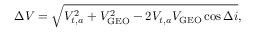<formula> <loc_0><loc_0><loc_500><loc_500>\Delta V = { \sqrt { V _ { t , a } ^ { 2 } + V _ { G E O } ^ { 2 } - 2 V _ { t , a } V _ { G E O } \cos \Delta i } } ,</formula> 